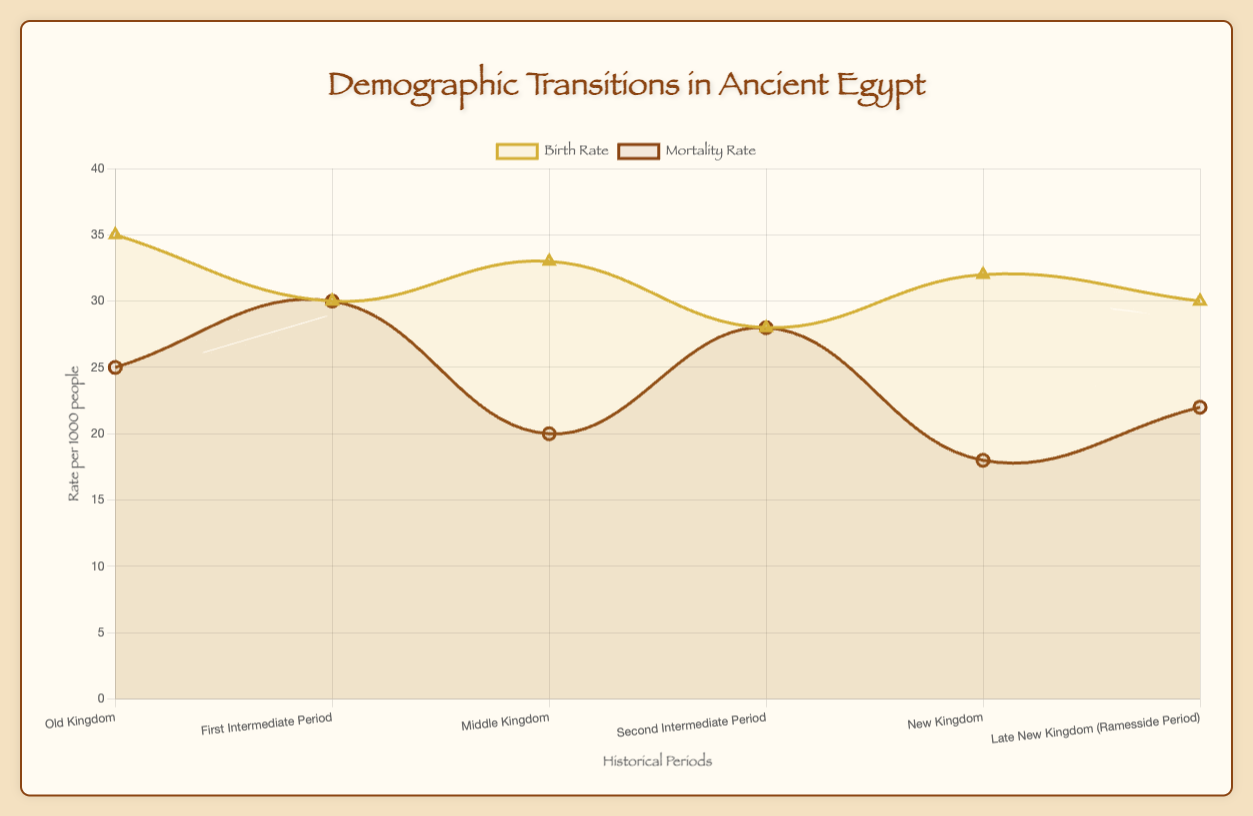What period had the highest birth rate and what was the value? The chart shows that the Old Kingdom had the highest birth rate. We can see that the line representing the birth rate peaks during the Old Kingdom period.
Answer: Old Kingdom, 35 per 1000 people Which period had the lowest mortality rate and what was the value? Observing the chart, the period with the lowest mortality rate is the New Kingdom. The line representing the mortality rate drops to its lowest point during this period.
Answer: New Kingdom, 18 per 1000 people During which periods were birth and mortality rates equal? The birth rate and mortality rates were equal during the First Intermediate Period and the Second Intermediate Period, where both lines converge.
Answer: First Intermediate Period and Second Intermediate Period What is the average birth rate across all periods? Summing the birth rates across the six periods (35 + 30 + 33 + 28 + 32 + 30) gives 188. Dividing by the number of periods (6) gives the average birth rate.
Answer: 31.33 per 1000 people What is the difference in mortality rate between the Old Kingdom and the New Kingdom? The mortality rate in the Old Kingdom was 25, whereas in the New Kingdom it was 18. The difference can be calculated as 25 - 18.
Answer: 7 per 1000 people Which period had a higher birth rate: the New Kingdom or the Late New Kingdom (Ramesside Period)? From the chart, we see that the New Kingdom had a birth rate of 32, while the Late New Kingdom had a birth rate of 30. Thus, the New Kingdom had a higher birth rate.
Answer: New Kingdom Considering birth and mortality rates, during which historical period does the population appear to have been the most stable? A stable population is indicated when birth and mortality rates are close to each other. This happens during the First Intermediate Period and the Second Intermediate Period where both rates are equal.
Answer: First Intermediate Period and Second Intermediate Period What was the change in birth rate from the First Intermediate Period to the Middle Kingdom? The birth rate in the First Intermediate Period was 30, and it increased to 33 in the Middle Kingdom. The change can be calculated as 33 - 30.
Answer: +3 per 1000 people Considering the trend, which period shows the most significant decline in mortality rate? Observing the slope of the mortality rate line, the most significant decline in mortality rate appears from the First Intermediate Period to the Middle Kingdom.
Answer: Middle Kingdom What were the notable events during the period with the lowest mortality rate? The period with the lowest mortality rate is the New Kingdom. The notable events during this period include Expansive Military Campaigns and Cultural Renaissance.
Answer: Expansive Military Campaigns and Cultural Renaissance 